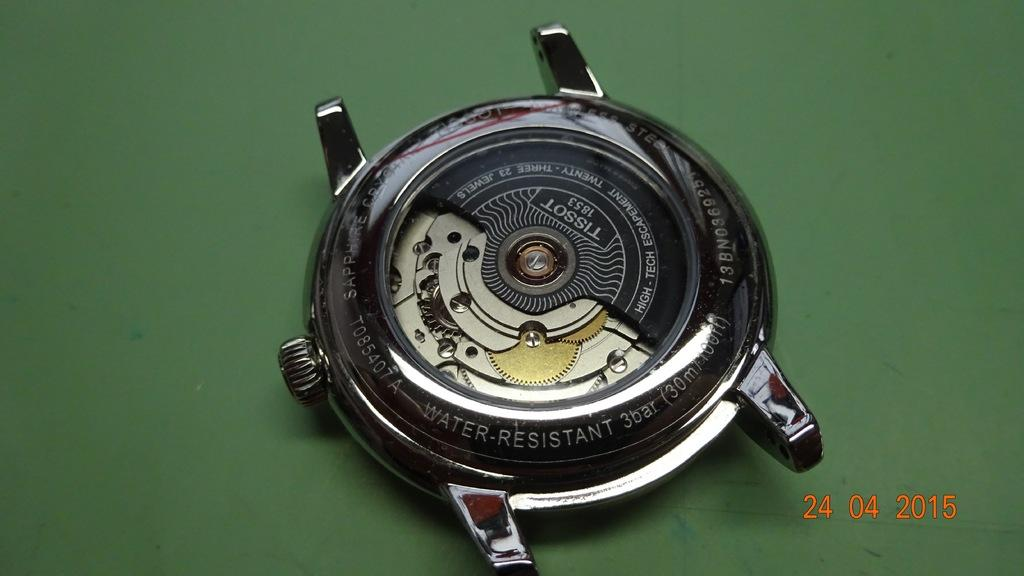<image>
Describe the image concisely. Tissot 1853 has its face removed and sits on a green table. 